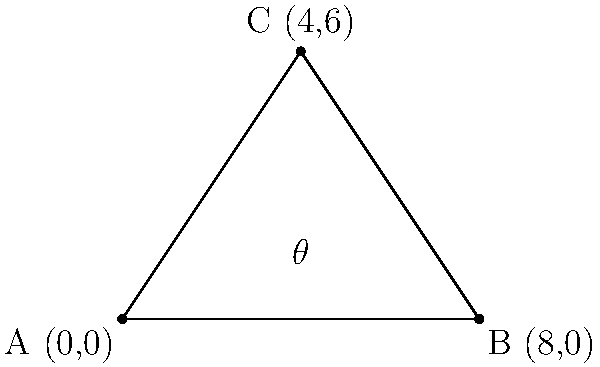In a theater, two spotlights are positioned on a grid system. Spotlight A is at coordinates (0,0), spotlight B is at (8,0), and the performer is at point C with coordinates (4,6). What is the angle $\theta$ (in degrees) between the two spotlights when focused on the performer? To find the angle between the two spotlights, we can use the law of cosines. Here's how:

1) First, calculate the distances:
   AC = $\sqrt{(4-0)^2 + (6-0)^2} = \sqrt{16 + 36} = \sqrt{52}$
   BC = $\sqrt{(4-8)^2 + (6-0)^2} = \sqrt{16 + 36} = \sqrt{52}$
   AB = 8

2) Now, apply the law of cosines:
   $\cos(\theta) = \frac{AC^2 + BC^2 - AB^2}{2(AC)(BC)}$

3) Substitute the values:
   $\cos(\theta) = \frac{52 + 52 - 64}{2\sqrt{52}\sqrt{52}} = \frac{40}{104} = \frac{10}{26}$

4) Take the inverse cosine (arccos) of both sides:
   $\theta = \arccos(\frac{10}{26})$

5) Calculate this value:
   $\theta \approx 67.38°$

6) Round to the nearest degree:
   $\theta \approx 67°$
Answer: 67° 